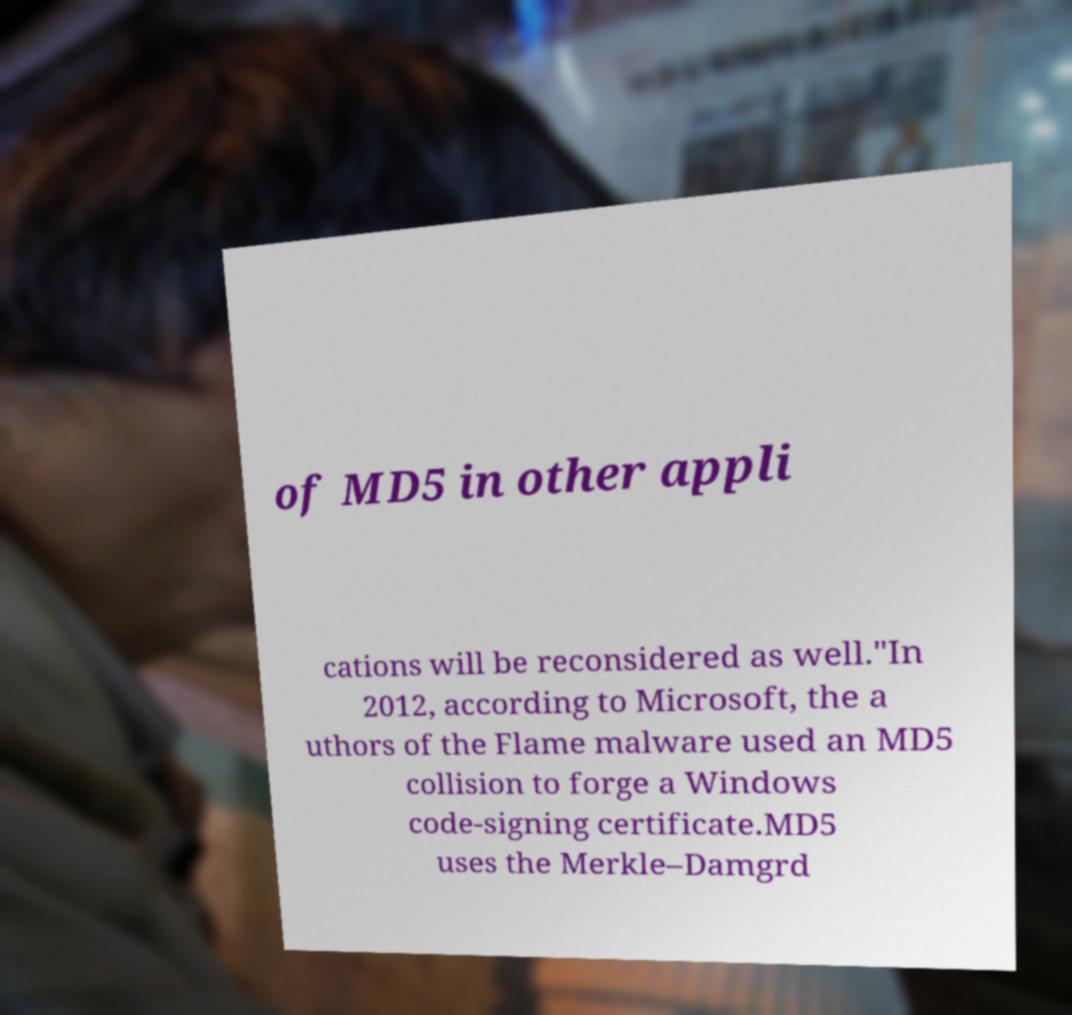There's text embedded in this image that I need extracted. Can you transcribe it verbatim? of MD5 in other appli cations will be reconsidered as well."In 2012, according to Microsoft, the a uthors of the Flame malware used an MD5 collision to forge a Windows code-signing certificate.MD5 uses the Merkle–Damgrd 